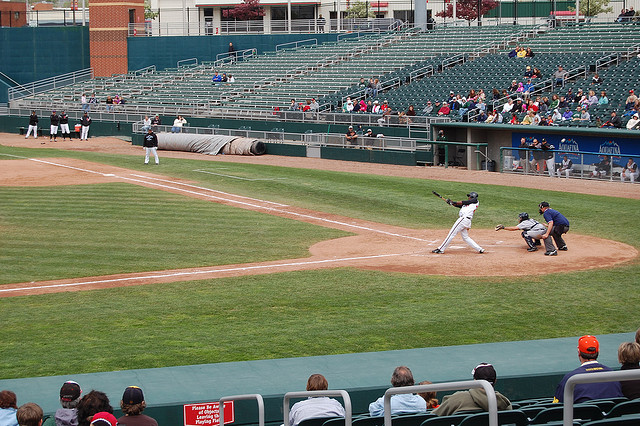How many players in baseball team? The typical number of players on a baseball team during a game is nine. These nine players consist of a pitcher, catcher, four infielders (first baseman, second baseman, shortstop, third baseman), and three outfielders (left fielder, center fielder, right fielder). 